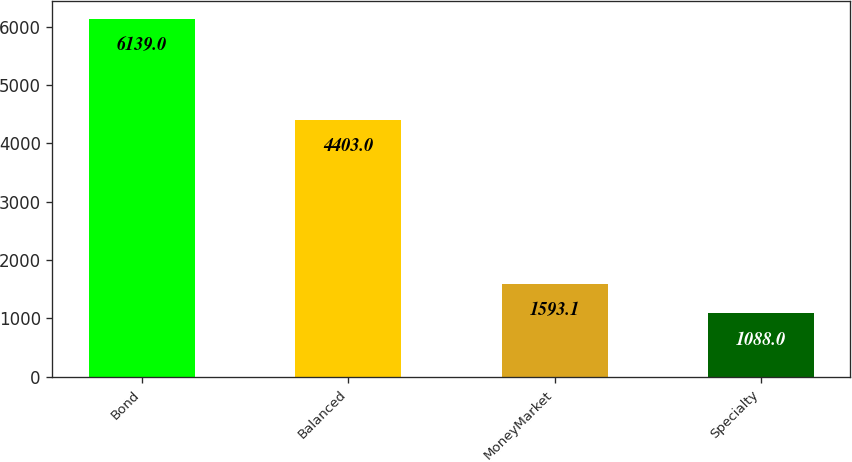Convert chart. <chart><loc_0><loc_0><loc_500><loc_500><bar_chart><fcel>Bond<fcel>Balanced<fcel>MoneyMarket<fcel>Specialty<nl><fcel>6139<fcel>4403<fcel>1593.1<fcel>1088<nl></chart> 